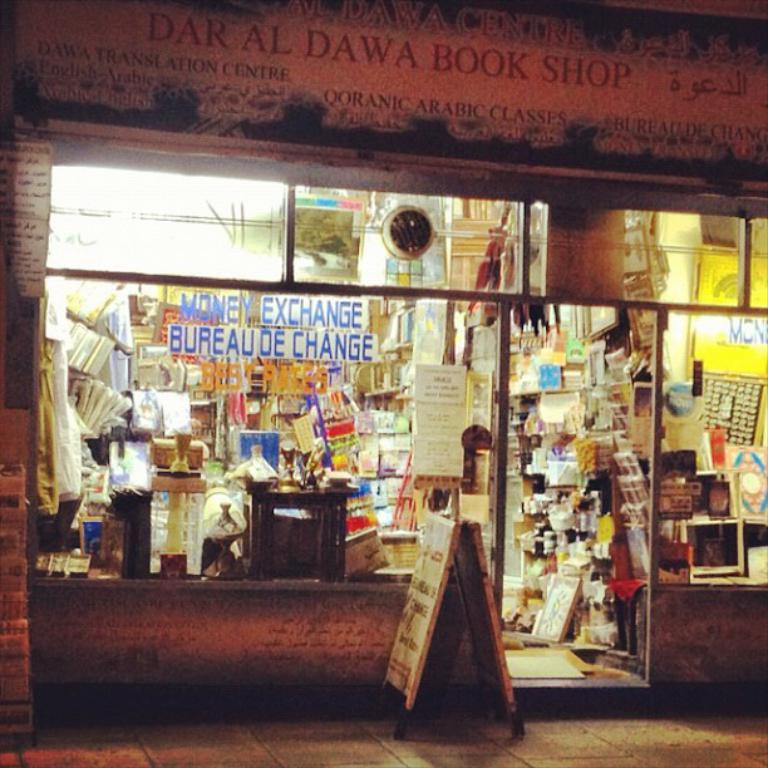Provide a one-sentence caption for the provided image. A book store called Daral Dawa Book Shop is open on a dark street. 